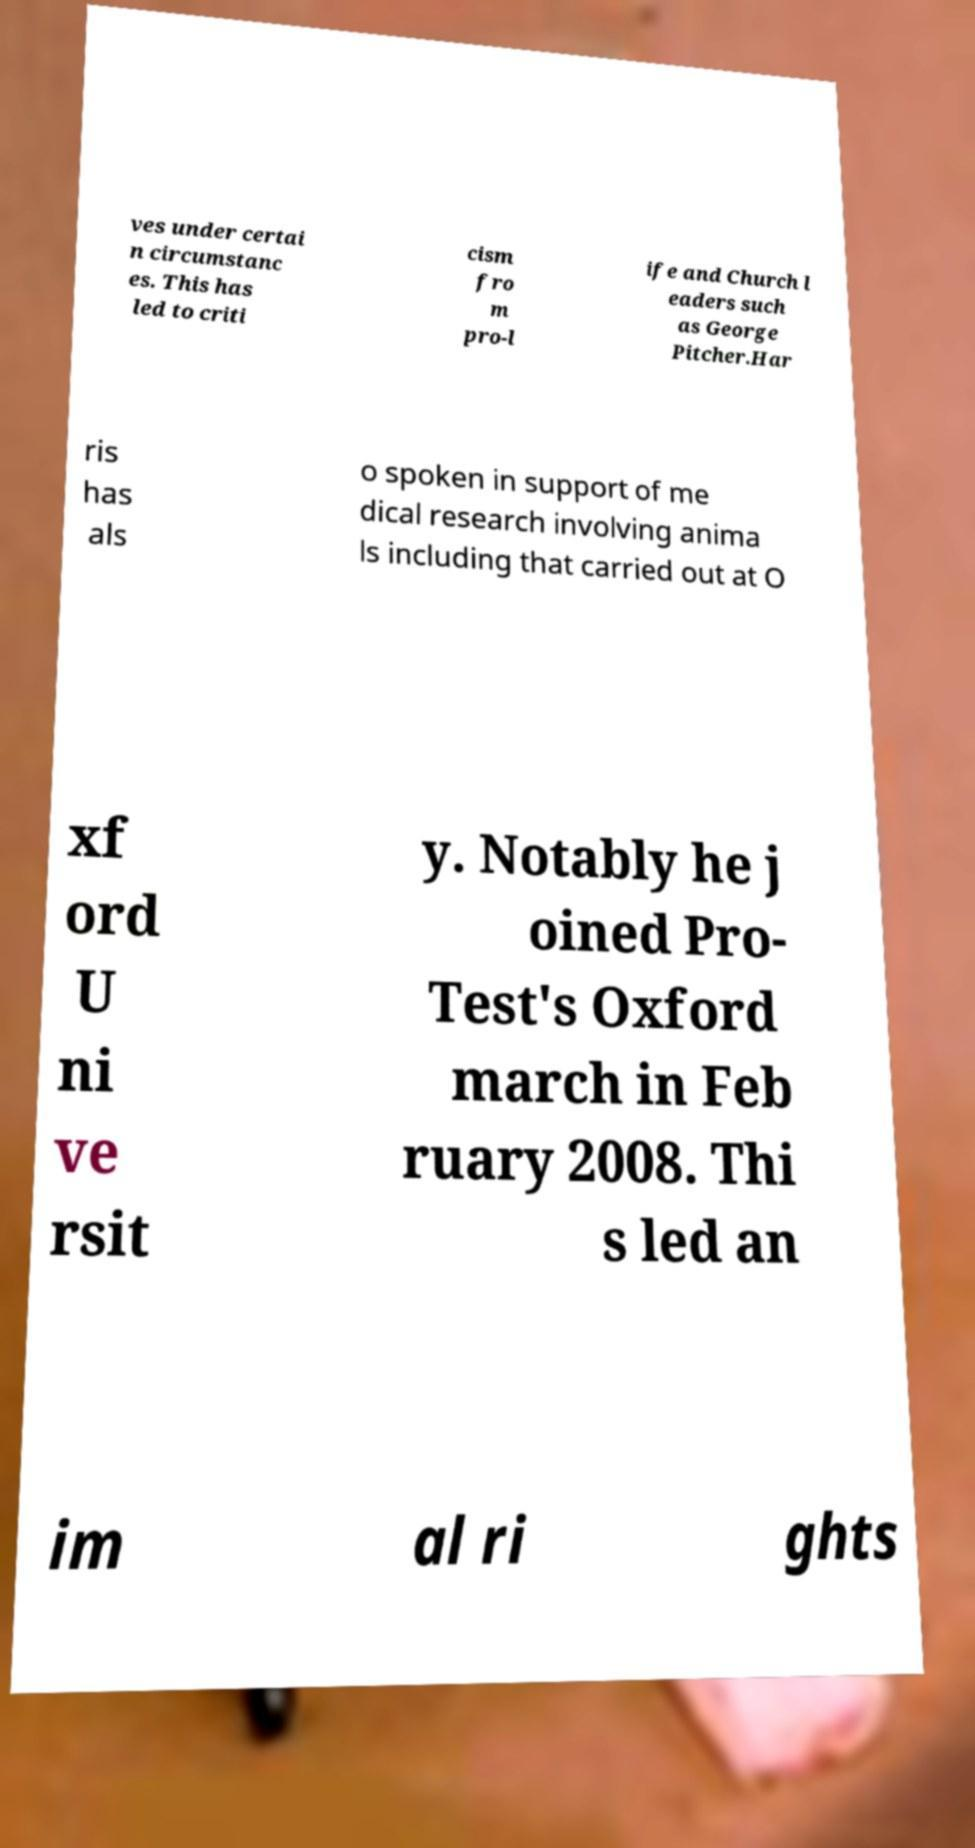Please identify and transcribe the text found in this image. ves under certai n circumstanc es. This has led to criti cism fro m pro-l ife and Church l eaders such as George Pitcher.Har ris has als o spoken in support of me dical research involving anima ls including that carried out at O xf ord U ni ve rsit y. Notably he j oined Pro- Test's Oxford march in Feb ruary 2008. Thi s led an im al ri ghts 